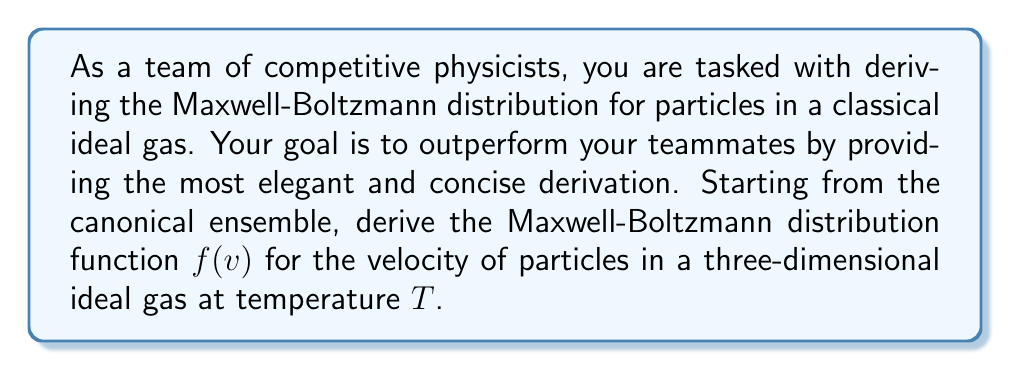Help me with this question. Let's derive the Maxwell-Boltzmann distribution step-by-step:

1) In the canonical ensemble, the probability of a particle having energy $E$ is proportional to the Boltzmann factor:

   $$P(E) \propto e^{-E/kT}$$

   where $k$ is the Boltzmann constant and $T$ is the temperature.

2) For a particle in an ideal gas, the energy is purely kinetic:

   $$E = \frac{1}{2}mv^2$$

   where $m$ is the mass of the particle and $v$ is its speed.

3) Substituting this into the Boltzmann factor:

   $$P(v) \propto e^{-mv^2/2kT}$$

4) The distribution function $f(v)$ should be normalized such that integrating over all velocities gives 1:

   $$\int_0^\infty 4\pi v^2 f(v) dv = 1$$

   The factor $4\pi v^2$ comes from the volume element in spherical coordinates.

5) Therefore, we can write:

   $$f(v) = A v^2 e^{-mv^2/2kT}$$

   where $A$ is a normalization constant.

6) To find $A$, we solve:

   $$\int_0^\infty 4\pi A v^2 e^{-mv^2/2kT} dv = 1$$

7) This integral can be solved using the substitution $u = mv^2/2kT$ and recognizing the resulting gamma function. The result is:

   $$A = \left(\frac{m}{2\pi kT}\right)^{3/2}$$

8) Therefore, the final Maxwell-Boltzmann distribution is:

   $$f(v) = 4\pi \left(\frac{m}{2\pi kT}\right)^{3/2} v^2 e^{-mv^2/2kT}$$

This gives the probability distribution for the speed $v$ of particles in a three-dimensional ideal gas at temperature $T$.
Answer: $$f(v) = 4\pi \left(\frac{m}{2\pi kT}\right)^{3/2} v^2 e^{-mv^2/2kT}$$ 